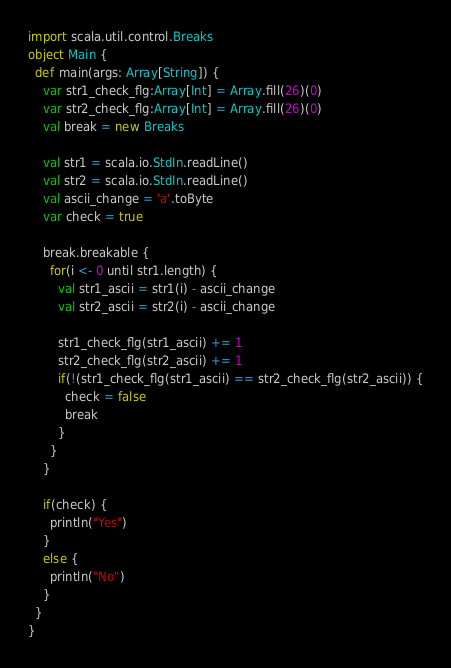<code> <loc_0><loc_0><loc_500><loc_500><_Scala_>import scala.util.control.Breaks
object Main {
  def main(args: Array[String]) {
    var str1_check_flg:Array[Int] = Array.fill(26)(0)
    var str2_check_flg:Array[Int] = Array.fill(26)(0)
    val break = new Breaks

    val str1 = scala.io.StdIn.readLine()
    val str2 = scala.io.StdIn.readLine()
    val ascii_change = 'a'.toByte
    var check = true

    break.breakable {
      for(i <- 0 until str1.length) {
        val str1_ascii = str1(i) - ascii_change
        val str2_ascii = str2(i) - ascii_change
        
        str1_check_flg(str1_ascii) += 1
        str2_check_flg(str2_ascii) += 1
        if(!(str1_check_flg(str1_ascii) == str2_check_flg(str2_ascii)) {
          check = false
          break
        }
      }
    }

    if(check) {
      println("Yes")
    }
    else {
      println("No")
    }
  }
}</code> 